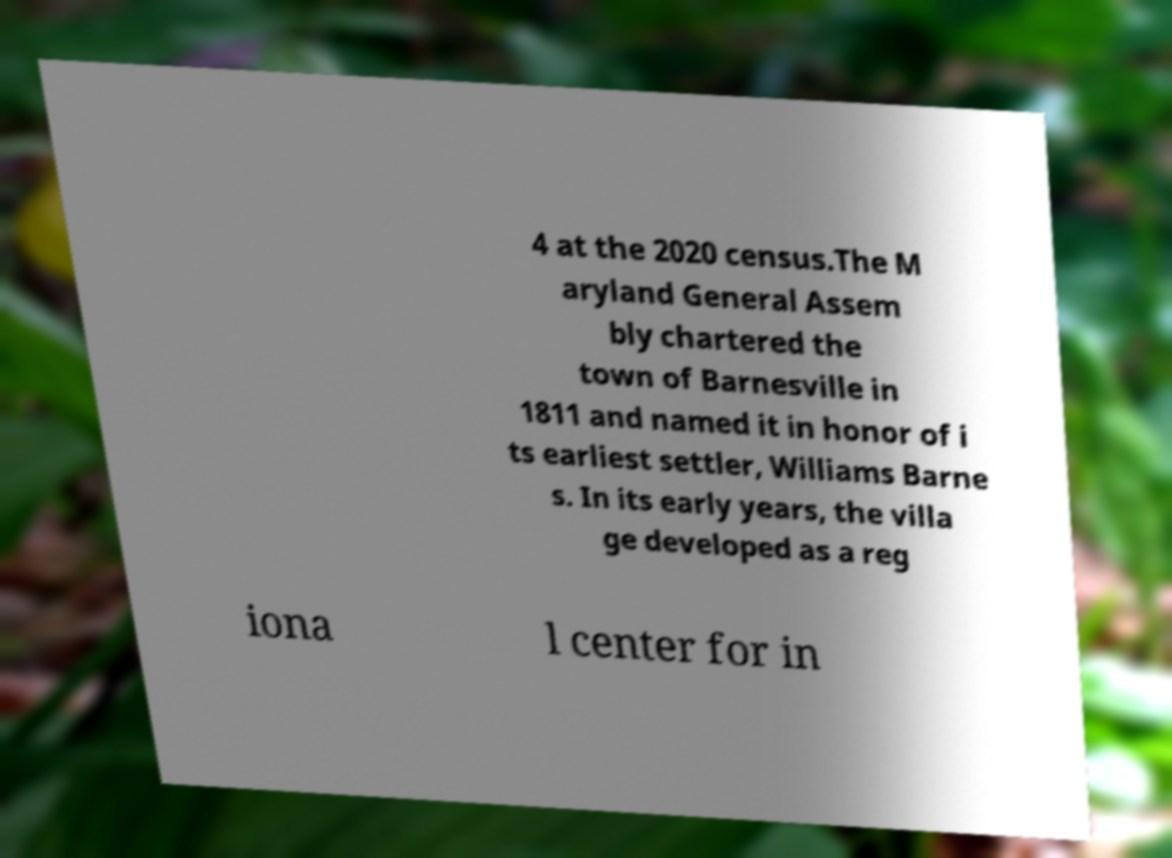What messages or text are displayed in this image? I need them in a readable, typed format. 4 at the 2020 census.The M aryland General Assem bly chartered the town of Barnesville in 1811 and named it in honor of i ts earliest settler, Williams Barne s. In its early years, the villa ge developed as a reg iona l center for in 